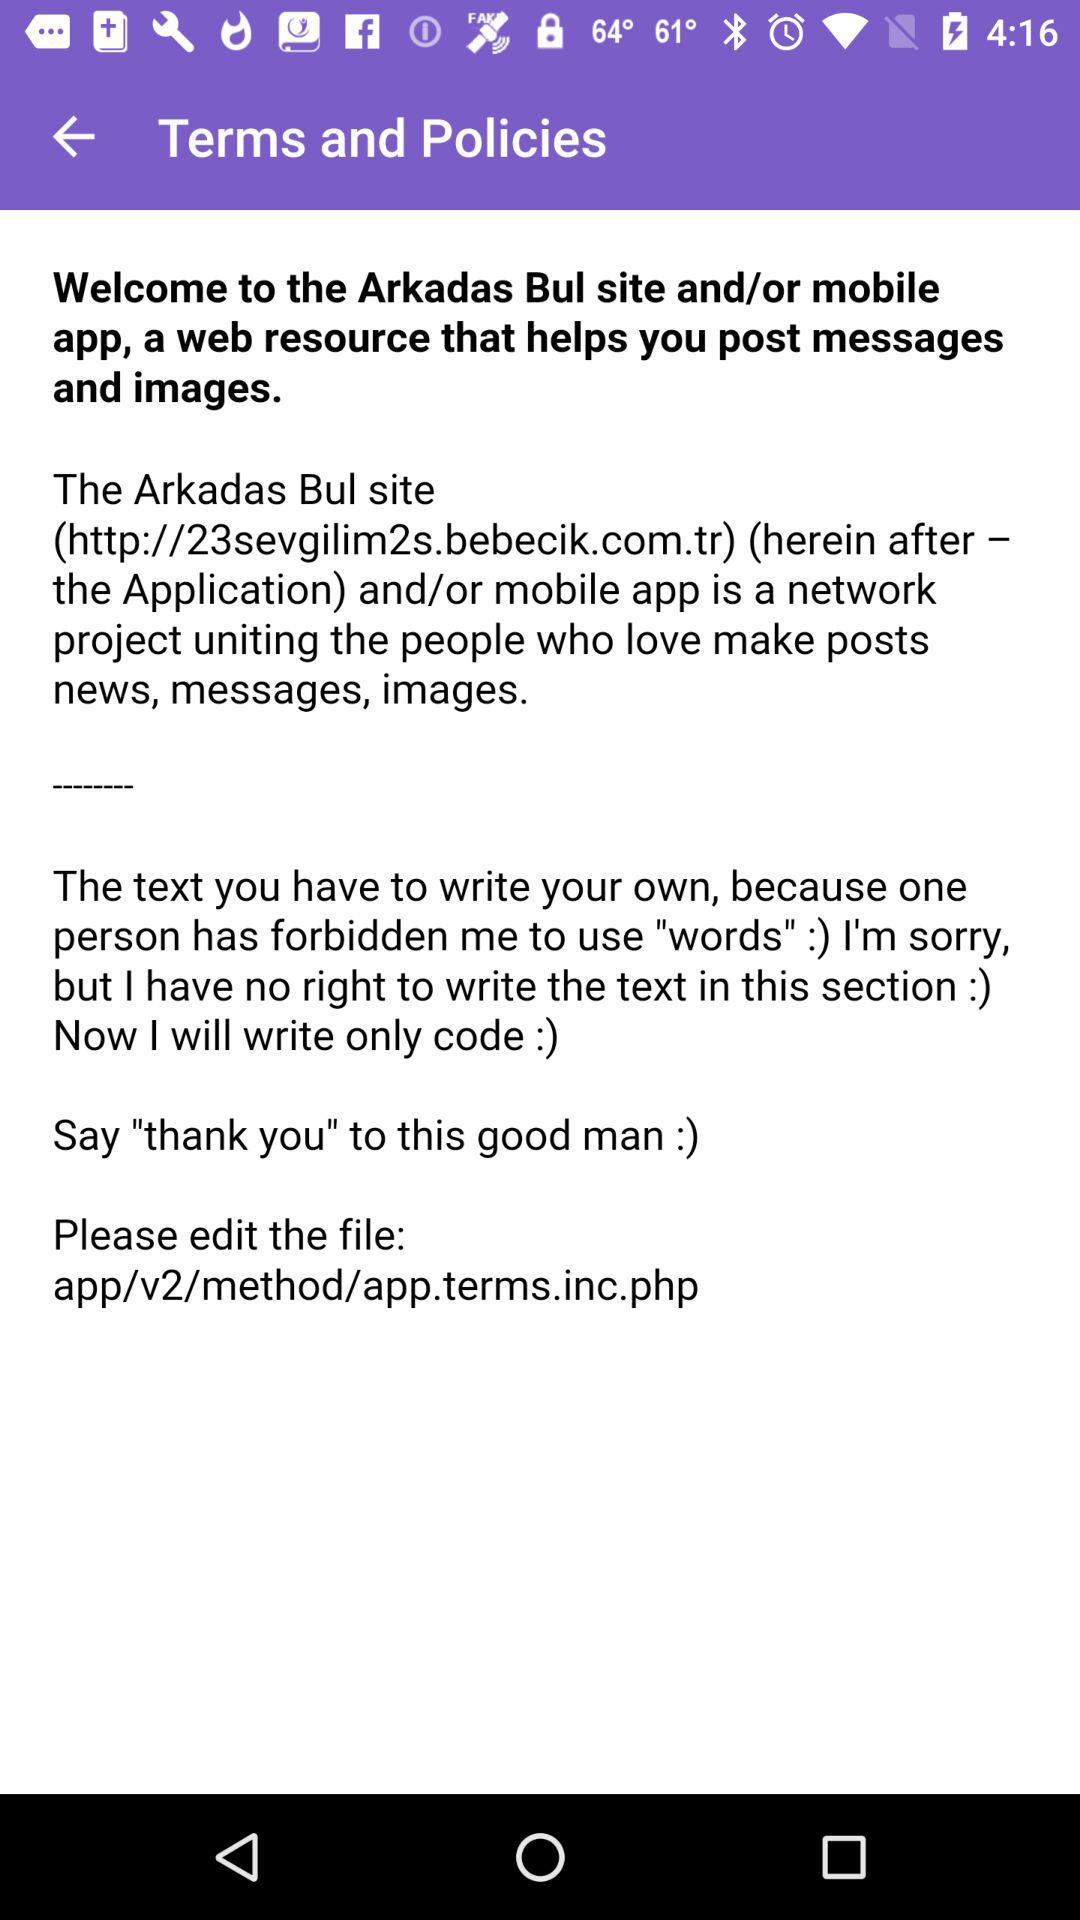What's the "Arkadas Bul site"? The "Arkadas Bul site" is a network project uniting the people who love make posts news, messages and images. 